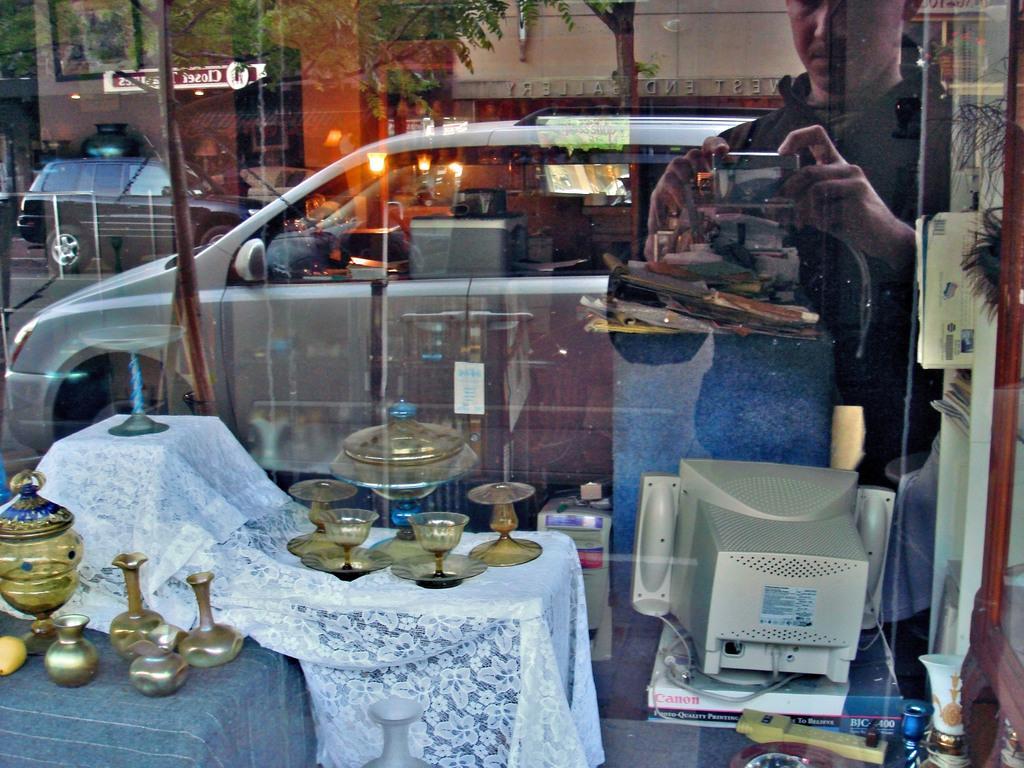Describe this image in one or two sentences. This picture is clicked on a glass. To the left corner of the image there is a table. On the table there is candle, candle holders and a cloth spread on it. To the right corner of the image there is a monitor on the books. On the above of it there is reflection of a man and he is holding a camera. At the center of the image there are cars, trees, lamps and a building. 